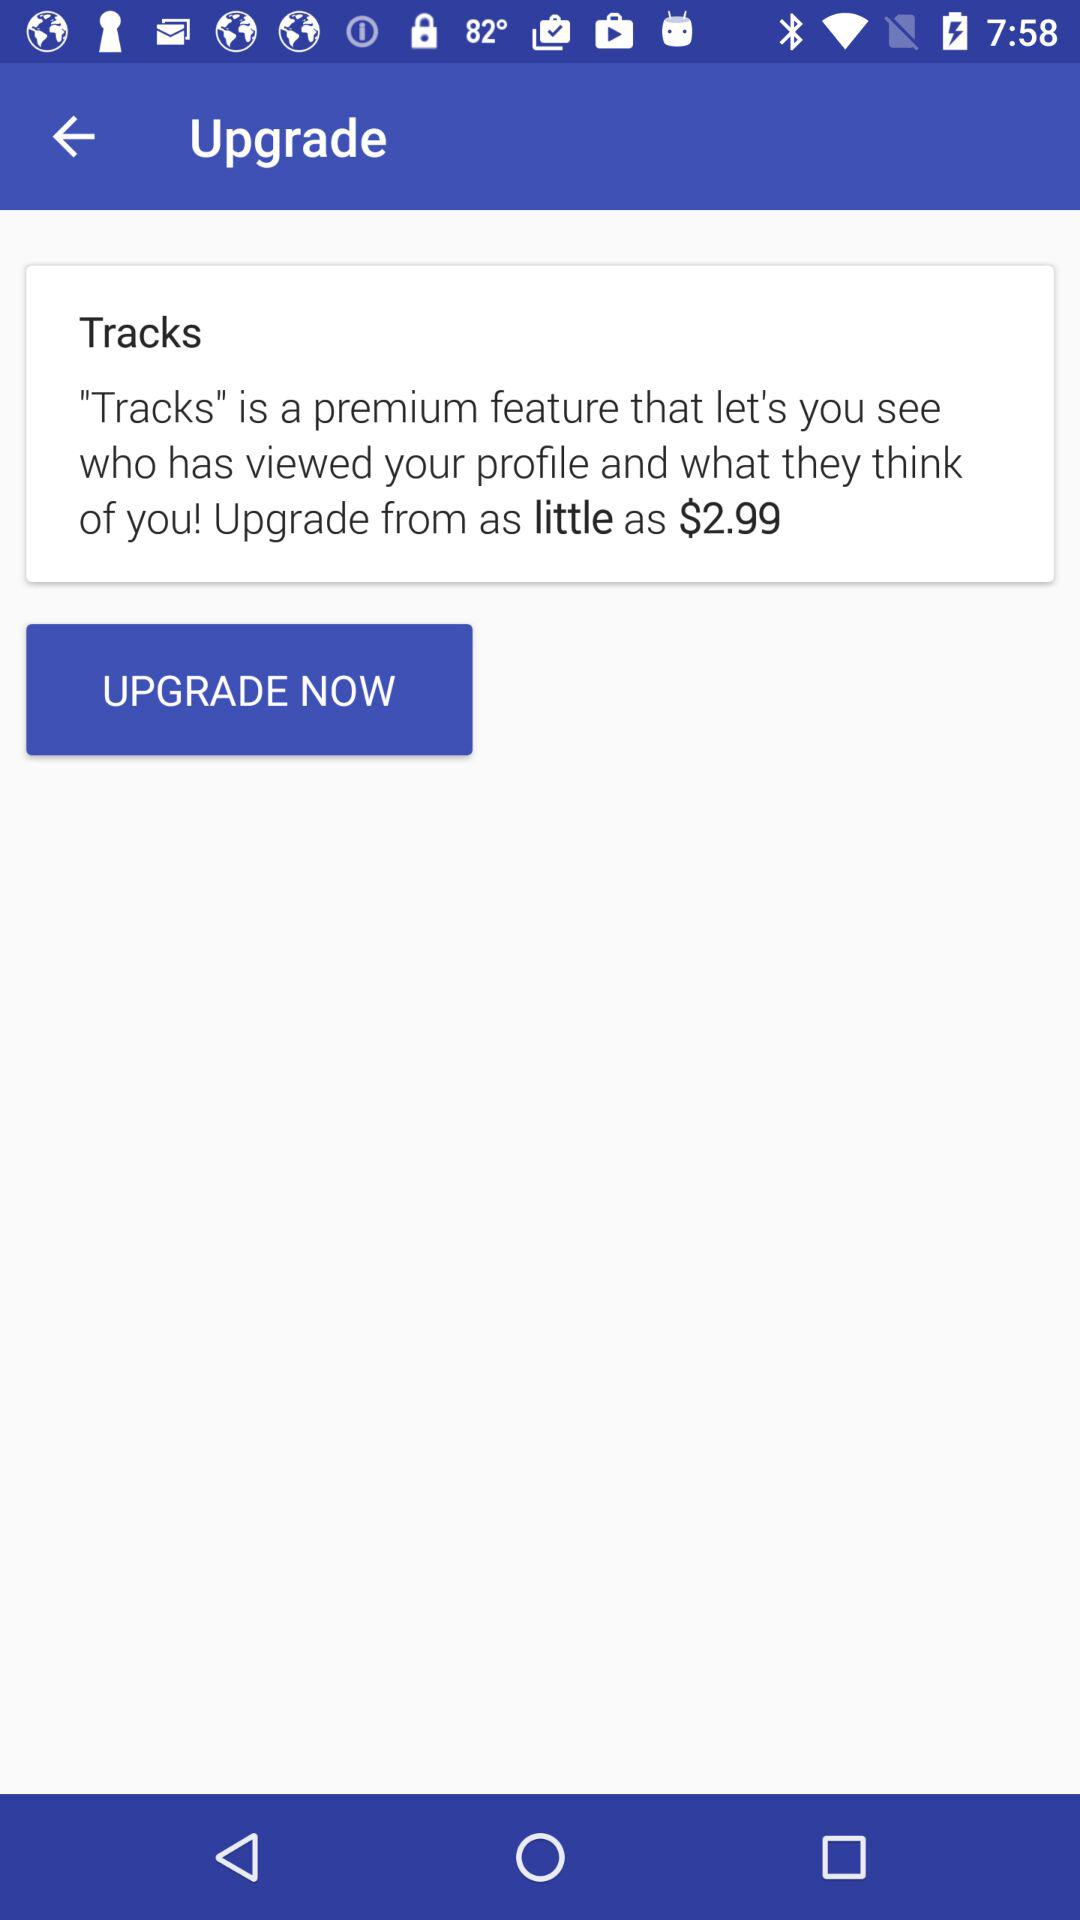What is the currency for the charge taken? The currency is $. 